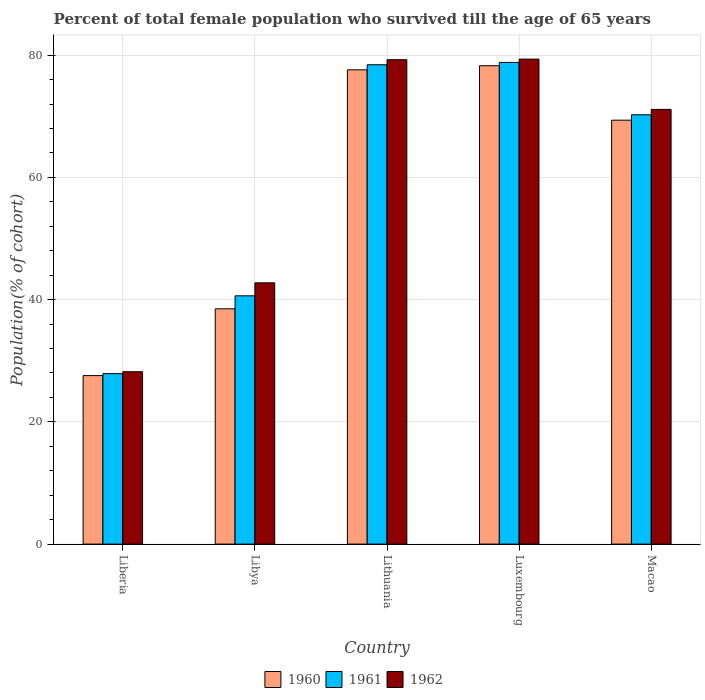How many different coloured bars are there?
Ensure brevity in your answer.  3. How many groups of bars are there?
Ensure brevity in your answer.  5. How many bars are there on the 4th tick from the left?
Provide a short and direct response. 3. How many bars are there on the 5th tick from the right?
Ensure brevity in your answer.  3. What is the label of the 4th group of bars from the left?
Your answer should be very brief. Luxembourg. In how many cases, is the number of bars for a given country not equal to the number of legend labels?
Ensure brevity in your answer.  0. What is the percentage of total female population who survived till the age of 65 years in 1960 in Macao?
Offer a very short reply. 69.36. Across all countries, what is the maximum percentage of total female population who survived till the age of 65 years in 1961?
Offer a terse response. 78.81. Across all countries, what is the minimum percentage of total female population who survived till the age of 65 years in 1961?
Ensure brevity in your answer.  27.89. In which country was the percentage of total female population who survived till the age of 65 years in 1961 maximum?
Give a very brief answer. Luxembourg. In which country was the percentage of total female population who survived till the age of 65 years in 1961 minimum?
Give a very brief answer. Liberia. What is the total percentage of total female population who survived till the age of 65 years in 1962 in the graph?
Your answer should be very brief. 300.68. What is the difference between the percentage of total female population who survived till the age of 65 years in 1962 in Libya and that in Macao?
Provide a succinct answer. -28.38. What is the difference between the percentage of total female population who survived till the age of 65 years in 1960 in Liberia and the percentage of total female population who survived till the age of 65 years in 1961 in Libya?
Make the answer very short. -13.05. What is the average percentage of total female population who survived till the age of 65 years in 1962 per country?
Your answer should be very brief. 60.14. What is the difference between the percentage of total female population who survived till the age of 65 years of/in 1962 and percentage of total female population who survived till the age of 65 years of/in 1961 in Liberia?
Keep it short and to the point. 0.32. In how many countries, is the percentage of total female population who survived till the age of 65 years in 1961 greater than 4 %?
Ensure brevity in your answer.  5. What is the ratio of the percentage of total female population who survived till the age of 65 years in 1960 in Libya to that in Luxembourg?
Provide a succinct answer. 0.49. Is the percentage of total female population who survived till the age of 65 years in 1962 in Luxembourg less than that in Macao?
Ensure brevity in your answer.  No. What is the difference between the highest and the second highest percentage of total female population who survived till the age of 65 years in 1961?
Your answer should be compact. 8.18. What is the difference between the highest and the lowest percentage of total female population who survived till the age of 65 years in 1960?
Give a very brief answer. 50.7. In how many countries, is the percentage of total female population who survived till the age of 65 years in 1961 greater than the average percentage of total female population who survived till the age of 65 years in 1961 taken over all countries?
Offer a terse response. 3. Is the sum of the percentage of total female population who survived till the age of 65 years in 1961 in Liberia and Lithuania greater than the maximum percentage of total female population who survived till the age of 65 years in 1962 across all countries?
Provide a succinct answer. Yes. What does the 1st bar from the left in Macao represents?
Ensure brevity in your answer.  1960. What does the 1st bar from the right in Luxembourg represents?
Ensure brevity in your answer.  1962. Is it the case that in every country, the sum of the percentage of total female population who survived till the age of 65 years in 1962 and percentage of total female population who survived till the age of 65 years in 1960 is greater than the percentage of total female population who survived till the age of 65 years in 1961?
Provide a short and direct response. Yes. Are all the bars in the graph horizontal?
Your response must be concise. No. How many legend labels are there?
Offer a very short reply. 3. What is the title of the graph?
Your answer should be very brief. Percent of total female population who survived till the age of 65 years. What is the label or title of the Y-axis?
Your response must be concise. Population(% of cohort). What is the Population(% of cohort) of 1960 in Liberia?
Your response must be concise. 27.57. What is the Population(% of cohort) of 1961 in Liberia?
Make the answer very short. 27.89. What is the Population(% of cohort) in 1962 in Liberia?
Give a very brief answer. 28.2. What is the Population(% of cohort) in 1960 in Libya?
Make the answer very short. 38.5. What is the Population(% of cohort) in 1961 in Libya?
Ensure brevity in your answer.  40.62. What is the Population(% of cohort) of 1962 in Libya?
Give a very brief answer. 42.75. What is the Population(% of cohort) in 1960 in Lithuania?
Offer a very short reply. 77.6. What is the Population(% of cohort) in 1961 in Lithuania?
Ensure brevity in your answer.  78.43. What is the Population(% of cohort) in 1962 in Lithuania?
Give a very brief answer. 79.25. What is the Population(% of cohort) of 1960 in Luxembourg?
Offer a very short reply. 78.27. What is the Population(% of cohort) of 1961 in Luxembourg?
Give a very brief answer. 78.81. What is the Population(% of cohort) of 1962 in Luxembourg?
Give a very brief answer. 79.35. What is the Population(% of cohort) of 1960 in Macao?
Keep it short and to the point. 69.36. What is the Population(% of cohort) of 1961 in Macao?
Your answer should be very brief. 70.24. What is the Population(% of cohort) of 1962 in Macao?
Your answer should be very brief. 71.13. Across all countries, what is the maximum Population(% of cohort) of 1960?
Your answer should be compact. 78.27. Across all countries, what is the maximum Population(% of cohort) in 1961?
Offer a terse response. 78.81. Across all countries, what is the maximum Population(% of cohort) in 1962?
Keep it short and to the point. 79.35. Across all countries, what is the minimum Population(% of cohort) of 1960?
Provide a succinct answer. 27.57. Across all countries, what is the minimum Population(% of cohort) of 1961?
Provide a short and direct response. 27.89. Across all countries, what is the minimum Population(% of cohort) of 1962?
Make the answer very short. 28.2. What is the total Population(% of cohort) in 1960 in the graph?
Your response must be concise. 291.3. What is the total Population(% of cohort) of 1961 in the graph?
Offer a very short reply. 295.99. What is the total Population(% of cohort) of 1962 in the graph?
Keep it short and to the point. 300.68. What is the difference between the Population(% of cohort) in 1960 in Liberia and that in Libya?
Provide a short and direct response. -10.93. What is the difference between the Population(% of cohort) of 1961 in Liberia and that in Libya?
Your answer should be compact. -12.74. What is the difference between the Population(% of cohort) in 1962 in Liberia and that in Libya?
Provide a short and direct response. -14.55. What is the difference between the Population(% of cohort) in 1960 in Liberia and that in Lithuania?
Provide a succinct answer. -50.03. What is the difference between the Population(% of cohort) in 1961 in Liberia and that in Lithuania?
Make the answer very short. -50.54. What is the difference between the Population(% of cohort) in 1962 in Liberia and that in Lithuania?
Provide a short and direct response. -51.05. What is the difference between the Population(% of cohort) in 1960 in Liberia and that in Luxembourg?
Give a very brief answer. -50.7. What is the difference between the Population(% of cohort) of 1961 in Liberia and that in Luxembourg?
Your answer should be very brief. -50.93. What is the difference between the Population(% of cohort) in 1962 in Liberia and that in Luxembourg?
Give a very brief answer. -51.15. What is the difference between the Population(% of cohort) of 1960 in Liberia and that in Macao?
Offer a very short reply. -41.79. What is the difference between the Population(% of cohort) of 1961 in Liberia and that in Macao?
Give a very brief answer. -42.36. What is the difference between the Population(% of cohort) in 1962 in Liberia and that in Macao?
Make the answer very short. -42.92. What is the difference between the Population(% of cohort) of 1960 in Libya and that in Lithuania?
Provide a short and direct response. -39.1. What is the difference between the Population(% of cohort) in 1961 in Libya and that in Lithuania?
Keep it short and to the point. -37.8. What is the difference between the Population(% of cohort) in 1962 in Libya and that in Lithuania?
Provide a succinct answer. -36.51. What is the difference between the Population(% of cohort) of 1960 in Libya and that in Luxembourg?
Offer a terse response. -39.77. What is the difference between the Population(% of cohort) of 1961 in Libya and that in Luxembourg?
Provide a succinct answer. -38.19. What is the difference between the Population(% of cohort) in 1962 in Libya and that in Luxembourg?
Provide a succinct answer. -36.6. What is the difference between the Population(% of cohort) in 1960 in Libya and that in Macao?
Make the answer very short. -30.86. What is the difference between the Population(% of cohort) in 1961 in Libya and that in Macao?
Your answer should be very brief. -29.62. What is the difference between the Population(% of cohort) of 1962 in Libya and that in Macao?
Provide a succinct answer. -28.38. What is the difference between the Population(% of cohort) in 1960 in Lithuania and that in Luxembourg?
Provide a short and direct response. -0.68. What is the difference between the Population(% of cohort) in 1961 in Lithuania and that in Luxembourg?
Offer a very short reply. -0.39. What is the difference between the Population(% of cohort) of 1962 in Lithuania and that in Luxembourg?
Make the answer very short. -0.1. What is the difference between the Population(% of cohort) in 1960 in Lithuania and that in Macao?
Ensure brevity in your answer.  8.24. What is the difference between the Population(% of cohort) of 1961 in Lithuania and that in Macao?
Keep it short and to the point. 8.18. What is the difference between the Population(% of cohort) of 1962 in Lithuania and that in Macao?
Offer a very short reply. 8.13. What is the difference between the Population(% of cohort) in 1960 in Luxembourg and that in Macao?
Your answer should be compact. 8.91. What is the difference between the Population(% of cohort) in 1961 in Luxembourg and that in Macao?
Your answer should be very brief. 8.57. What is the difference between the Population(% of cohort) in 1962 in Luxembourg and that in Macao?
Give a very brief answer. 8.22. What is the difference between the Population(% of cohort) in 1960 in Liberia and the Population(% of cohort) in 1961 in Libya?
Make the answer very short. -13.05. What is the difference between the Population(% of cohort) in 1960 in Liberia and the Population(% of cohort) in 1962 in Libya?
Give a very brief answer. -15.18. What is the difference between the Population(% of cohort) of 1961 in Liberia and the Population(% of cohort) of 1962 in Libya?
Provide a short and direct response. -14.86. What is the difference between the Population(% of cohort) of 1960 in Liberia and the Population(% of cohort) of 1961 in Lithuania?
Keep it short and to the point. -50.86. What is the difference between the Population(% of cohort) in 1960 in Liberia and the Population(% of cohort) in 1962 in Lithuania?
Offer a terse response. -51.69. What is the difference between the Population(% of cohort) in 1961 in Liberia and the Population(% of cohort) in 1962 in Lithuania?
Offer a very short reply. -51.37. What is the difference between the Population(% of cohort) in 1960 in Liberia and the Population(% of cohort) in 1961 in Luxembourg?
Your answer should be compact. -51.24. What is the difference between the Population(% of cohort) in 1960 in Liberia and the Population(% of cohort) in 1962 in Luxembourg?
Your answer should be compact. -51.78. What is the difference between the Population(% of cohort) in 1961 in Liberia and the Population(% of cohort) in 1962 in Luxembourg?
Your answer should be compact. -51.47. What is the difference between the Population(% of cohort) of 1960 in Liberia and the Population(% of cohort) of 1961 in Macao?
Offer a very short reply. -42.67. What is the difference between the Population(% of cohort) in 1960 in Liberia and the Population(% of cohort) in 1962 in Macao?
Give a very brief answer. -43.56. What is the difference between the Population(% of cohort) in 1961 in Liberia and the Population(% of cohort) in 1962 in Macao?
Offer a very short reply. -43.24. What is the difference between the Population(% of cohort) in 1960 in Libya and the Population(% of cohort) in 1961 in Lithuania?
Give a very brief answer. -39.93. What is the difference between the Population(% of cohort) of 1960 in Libya and the Population(% of cohort) of 1962 in Lithuania?
Ensure brevity in your answer.  -40.76. What is the difference between the Population(% of cohort) of 1961 in Libya and the Population(% of cohort) of 1962 in Lithuania?
Provide a succinct answer. -38.63. What is the difference between the Population(% of cohort) in 1960 in Libya and the Population(% of cohort) in 1961 in Luxembourg?
Your answer should be very brief. -40.31. What is the difference between the Population(% of cohort) in 1960 in Libya and the Population(% of cohort) in 1962 in Luxembourg?
Provide a succinct answer. -40.85. What is the difference between the Population(% of cohort) in 1961 in Libya and the Population(% of cohort) in 1962 in Luxembourg?
Offer a terse response. -38.73. What is the difference between the Population(% of cohort) of 1960 in Libya and the Population(% of cohort) of 1961 in Macao?
Offer a very short reply. -31.75. What is the difference between the Population(% of cohort) of 1960 in Libya and the Population(% of cohort) of 1962 in Macao?
Keep it short and to the point. -32.63. What is the difference between the Population(% of cohort) of 1961 in Libya and the Population(% of cohort) of 1962 in Macao?
Your answer should be compact. -30.5. What is the difference between the Population(% of cohort) in 1960 in Lithuania and the Population(% of cohort) in 1961 in Luxembourg?
Give a very brief answer. -1.22. What is the difference between the Population(% of cohort) of 1960 in Lithuania and the Population(% of cohort) of 1962 in Luxembourg?
Provide a short and direct response. -1.75. What is the difference between the Population(% of cohort) in 1961 in Lithuania and the Population(% of cohort) in 1962 in Luxembourg?
Provide a short and direct response. -0.93. What is the difference between the Population(% of cohort) in 1960 in Lithuania and the Population(% of cohort) in 1961 in Macao?
Give a very brief answer. 7.35. What is the difference between the Population(% of cohort) in 1960 in Lithuania and the Population(% of cohort) in 1962 in Macao?
Your answer should be very brief. 6.47. What is the difference between the Population(% of cohort) of 1961 in Lithuania and the Population(% of cohort) of 1962 in Macao?
Offer a very short reply. 7.3. What is the difference between the Population(% of cohort) of 1960 in Luxembourg and the Population(% of cohort) of 1961 in Macao?
Offer a terse response. 8.03. What is the difference between the Population(% of cohort) in 1960 in Luxembourg and the Population(% of cohort) in 1962 in Macao?
Provide a short and direct response. 7.15. What is the difference between the Population(% of cohort) in 1961 in Luxembourg and the Population(% of cohort) in 1962 in Macao?
Keep it short and to the point. 7.69. What is the average Population(% of cohort) in 1960 per country?
Make the answer very short. 58.26. What is the average Population(% of cohort) of 1961 per country?
Offer a terse response. 59.2. What is the average Population(% of cohort) of 1962 per country?
Give a very brief answer. 60.14. What is the difference between the Population(% of cohort) of 1960 and Population(% of cohort) of 1961 in Liberia?
Provide a succinct answer. -0.32. What is the difference between the Population(% of cohort) in 1960 and Population(% of cohort) in 1962 in Liberia?
Offer a very short reply. -0.63. What is the difference between the Population(% of cohort) in 1961 and Population(% of cohort) in 1962 in Liberia?
Offer a very short reply. -0.32. What is the difference between the Population(% of cohort) of 1960 and Population(% of cohort) of 1961 in Libya?
Keep it short and to the point. -2.12. What is the difference between the Population(% of cohort) of 1960 and Population(% of cohort) of 1962 in Libya?
Give a very brief answer. -4.25. What is the difference between the Population(% of cohort) in 1961 and Population(% of cohort) in 1962 in Libya?
Keep it short and to the point. -2.12. What is the difference between the Population(% of cohort) in 1960 and Population(% of cohort) in 1961 in Lithuania?
Your answer should be very brief. -0.83. What is the difference between the Population(% of cohort) of 1960 and Population(% of cohort) of 1962 in Lithuania?
Provide a succinct answer. -1.66. What is the difference between the Population(% of cohort) in 1961 and Population(% of cohort) in 1962 in Lithuania?
Keep it short and to the point. -0.83. What is the difference between the Population(% of cohort) of 1960 and Population(% of cohort) of 1961 in Luxembourg?
Your answer should be very brief. -0.54. What is the difference between the Population(% of cohort) of 1960 and Population(% of cohort) of 1962 in Luxembourg?
Provide a short and direct response. -1.08. What is the difference between the Population(% of cohort) in 1961 and Population(% of cohort) in 1962 in Luxembourg?
Give a very brief answer. -0.54. What is the difference between the Population(% of cohort) in 1960 and Population(% of cohort) in 1961 in Macao?
Your answer should be very brief. -0.88. What is the difference between the Population(% of cohort) in 1960 and Population(% of cohort) in 1962 in Macao?
Your answer should be compact. -1.77. What is the difference between the Population(% of cohort) in 1961 and Population(% of cohort) in 1962 in Macao?
Keep it short and to the point. -0.88. What is the ratio of the Population(% of cohort) in 1960 in Liberia to that in Libya?
Offer a very short reply. 0.72. What is the ratio of the Population(% of cohort) in 1961 in Liberia to that in Libya?
Provide a succinct answer. 0.69. What is the ratio of the Population(% of cohort) in 1962 in Liberia to that in Libya?
Your answer should be very brief. 0.66. What is the ratio of the Population(% of cohort) in 1960 in Liberia to that in Lithuania?
Make the answer very short. 0.36. What is the ratio of the Population(% of cohort) of 1961 in Liberia to that in Lithuania?
Provide a succinct answer. 0.36. What is the ratio of the Population(% of cohort) in 1962 in Liberia to that in Lithuania?
Give a very brief answer. 0.36. What is the ratio of the Population(% of cohort) of 1960 in Liberia to that in Luxembourg?
Keep it short and to the point. 0.35. What is the ratio of the Population(% of cohort) in 1961 in Liberia to that in Luxembourg?
Your response must be concise. 0.35. What is the ratio of the Population(% of cohort) in 1962 in Liberia to that in Luxembourg?
Give a very brief answer. 0.36. What is the ratio of the Population(% of cohort) of 1960 in Liberia to that in Macao?
Keep it short and to the point. 0.4. What is the ratio of the Population(% of cohort) in 1961 in Liberia to that in Macao?
Make the answer very short. 0.4. What is the ratio of the Population(% of cohort) of 1962 in Liberia to that in Macao?
Your answer should be compact. 0.4. What is the ratio of the Population(% of cohort) in 1960 in Libya to that in Lithuania?
Offer a terse response. 0.5. What is the ratio of the Population(% of cohort) in 1961 in Libya to that in Lithuania?
Your answer should be very brief. 0.52. What is the ratio of the Population(% of cohort) in 1962 in Libya to that in Lithuania?
Keep it short and to the point. 0.54. What is the ratio of the Population(% of cohort) in 1960 in Libya to that in Luxembourg?
Your response must be concise. 0.49. What is the ratio of the Population(% of cohort) in 1961 in Libya to that in Luxembourg?
Ensure brevity in your answer.  0.52. What is the ratio of the Population(% of cohort) of 1962 in Libya to that in Luxembourg?
Your answer should be compact. 0.54. What is the ratio of the Population(% of cohort) in 1960 in Libya to that in Macao?
Provide a short and direct response. 0.56. What is the ratio of the Population(% of cohort) in 1961 in Libya to that in Macao?
Make the answer very short. 0.58. What is the ratio of the Population(% of cohort) in 1962 in Libya to that in Macao?
Your answer should be very brief. 0.6. What is the ratio of the Population(% of cohort) of 1960 in Lithuania to that in Luxembourg?
Keep it short and to the point. 0.99. What is the ratio of the Population(% of cohort) of 1962 in Lithuania to that in Luxembourg?
Provide a succinct answer. 1. What is the ratio of the Population(% of cohort) in 1960 in Lithuania to that in Macao?
Make the answer very short. 1.12. What is the ratio of the Population(% of cohort) of 1961 in Lithuania to that in Macao?
Offer a terse response. 1.12. What is the ratio of the Population(% of cohort) of 1962 in Lithuania to that in Macao?
Your answer should be compact. 1.11. What is the ratio of the Population(% of cohort) in 1960 in Luxembourg to that in Macao?
Your response must be concise. 1.13. What is the ratio of the Population(% of cohort) of 1961 in Luxembourg to that in Macao?
Offer a very short reply. 1.12. What is the ratio of the Population(% of cohort) in 1962 in Luxembourg to that in Macao?
Offer a terse response. 1.12. What is the difference between the highest and the second highest Population(% of cohort) in 1960?
Make the answer very short. 0.68. What is the difference between the highest and the second highest Population(% of cohort) in 1961?
Your answer should be compact. 0.39. What is the difference between the highest and the second highest Population(% of cohort) of 1962?
Provide a short and direct response. 0.1. What is the difference between the highest and the lowest Population(% of cohort) of 1960?
Provide a short and direct response. 50.7. What is the difference between the highest and the lowest Population(% of cohort) in 1961?
Provide a short and direct response. 50.93. What is the difference between the highest and the lowest Population(% of cohort) of 1962?
Offer a very short reply. 51.15. 